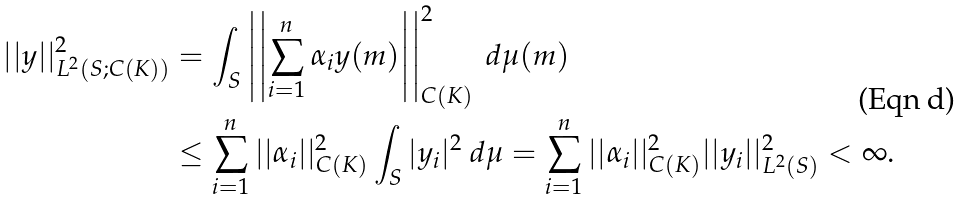<formula> <loc_0><loc_0><loc_500><loc_500>| | y | | _ { L ^ { 2 } ( S ; C ( K ) ) } ^ { 2 } & = \int _ { S } \left | \left | \sum _ { i = 1 } ^ { n } \alpha _ { i } y ( m ) \right | \right | _ { C ( K ) } ^ { 2 } \ d \mu ( m ) \\ & \leq \sum _ { i = 1 } ^ { n } | | \alpha _ { i } | | _ { C ( K ) } ^ { 2 } \int _ { S } | y _ { i } | ^ { 2 } \ d \mu = \sum _ { i = 1 } ^ { n } | | \alpha _ { i } | | _ { C ( K ) } ^ { 2 } | | y _ { i } | | _ { L ^ { 2 } ( S ) } ^ { 2 } < \infty .</formula> 